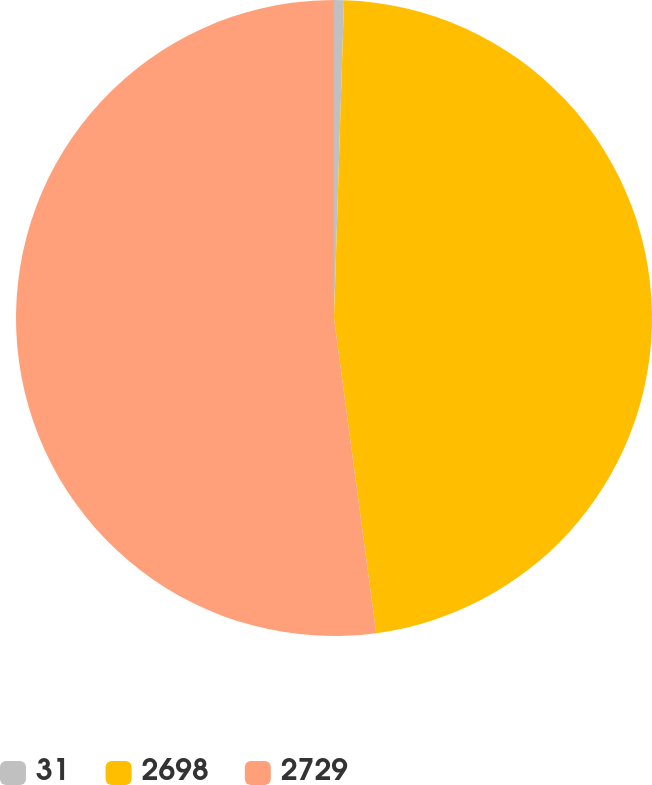Convert chart to OTSL. <chart><loc_0><loc_0><loc_500><loc_500><pie_chart><fcel>31<fcel>2698<fcel>2729<nl><fcel>0.5%<fcel>47.38%<fcel>52.12%<nl></chart> 